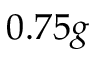<formula> <loc_0><loc_0><loc_500><loc_500>0 . 7 5 g</formula> 